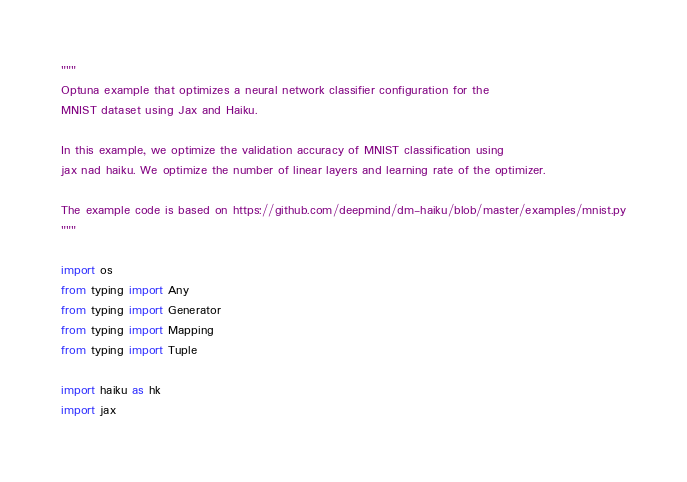<code> <loc_0><loc_0><loc_500><loc_500><_Python_>"""
Optuna example that optimizes a neural network classifier configuration for the
MNIST dataset using Jax and Haiku.

In this example, we optimize the validation accuracy of MNIST classification using
jax nad haiku. We optimize the number of linear layers and learning rate of the optimizer.

The example code is based on https://github.com/deepmind/dm-haiku/blob/master/examples/mnist.py
"""

import os
from typing import Any
from typing import Generator
from typing import Mapping
from typing import Tuple

import haiku as hk
import jax</code> 